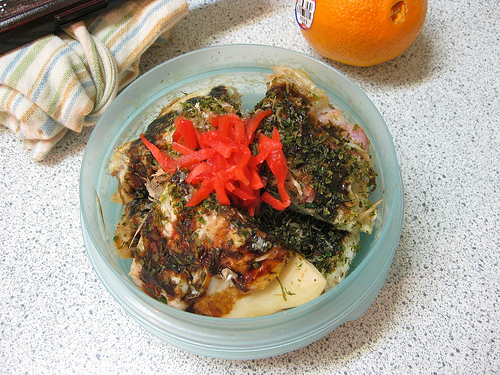<image>
Is there a orange to the right of the meal? Yes. From this viewpoint, the orange is positioned to the right side relative to the meal. 